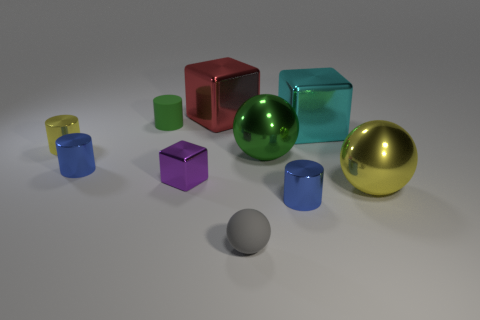What materials do the objects in the image seem to be made of? The objects in the image appear to be made of various materials. The shiny surfaces of the spheres suggest they could be metallic, while the cube and cylinders have a matte finish that might indicate plastic or painted wood materials. 